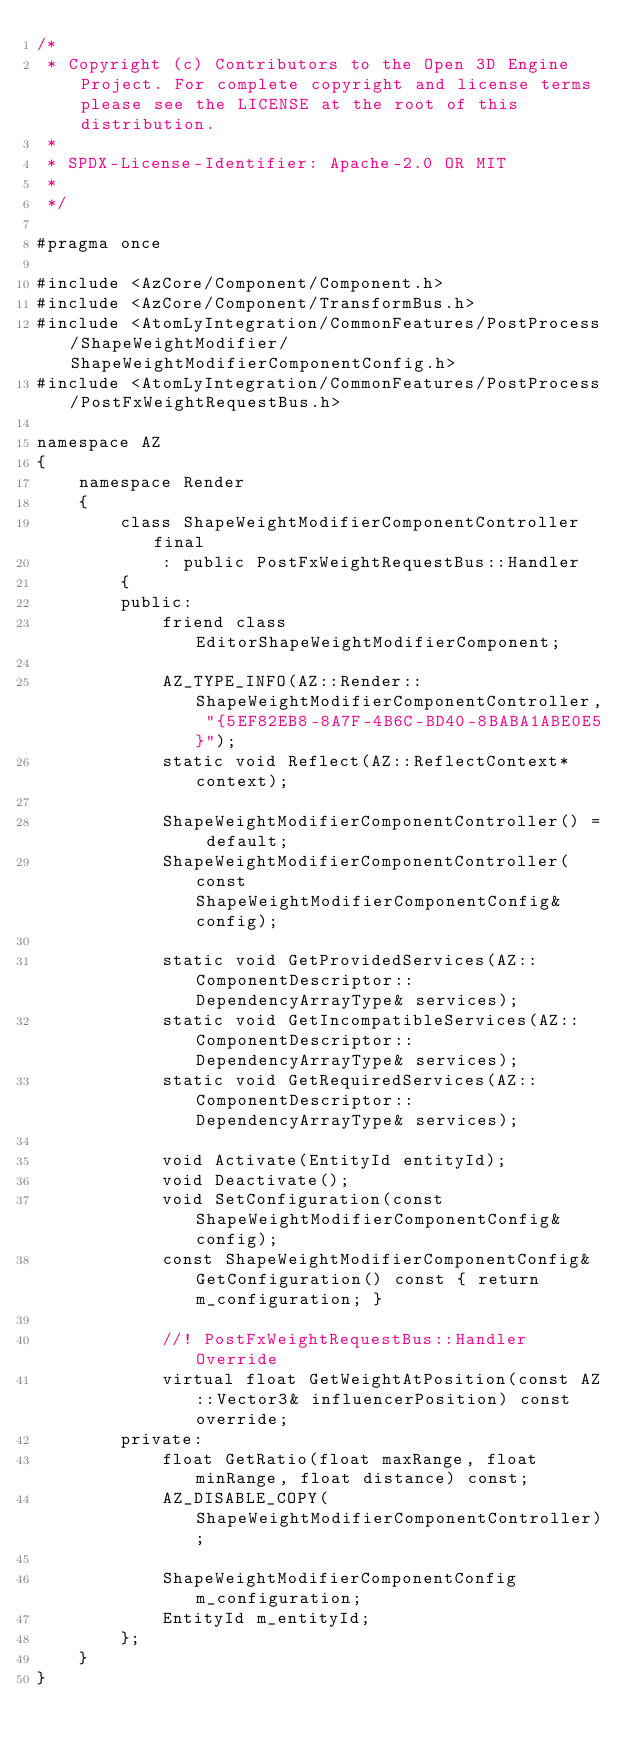Convert code to text. <code><loc_0><loc_0><loc_500><loc_500><_C_>/*
 * Copyright (c) Contributors to the Open 3D Engine Project. For complete copyright and license terms please see the LICENSE at the root of this distribution.
 * 
 * SPDX-License-Identifier: Apache-2.0 OR MIT
 *
 */

#pragma once

#include <AzCore/Component/Component.h>
#include <AzCore/Component/TransformBus.h>
#include <AtomLyIntegration/CommonFeatures/PostProcess/ShapeWeightModifier/ShapeWeightModifierComponentConfig.h>
#include <AtomLyIntegration/CommonFeatures/PostProcess/PostFxWeightRequestBus.h>

namespace AZ
{
    namespace Render
    {
        class ShapeWeightModifierComponentController final
            : public PostFxWeightRequestBus::Handler
        {
        public:
            friend class EditorShapeWeightModifierComponent;

            AZ_TYPE_INFO(AZ::Render::ShapeWeightModifierComponentController, "{5EF82EB8-8A7F-4B6C-BD40-8BABA1ABE0E5}");
            static void Reflect(AZ::ReflectContext* context);

            ShapeWeightModifierComponentController() = default;
            ShapeWeightModifierComponentController(const ShapeWeightModifierComponentConfig& config);

            static void GetProvidedServices(AZ::ComponentDescriptor::DependencyArrayType& services);
            static void GetIncompatibleServices(AZ::ComponentDescriptor::DependencyArrayType& services);
            static void GetRequiredServices(AZ::ComponentDescriptor::DependencyArrayType& services);

            void Activate(EntityId entityId);
            void Deactivate();
            void SetConfiguration(const ShapeWeightModifierComponentConfig& config);
            const ShapeWeightModifierComponentConfig& GetConfiguration() const { return m_configuration; }

            //! PostFxWeightRequestBus::Handler Override
            virtual float GetWeightAtPosition(const AZ::Vector3& influencerPosition) const override;
        private:
            float GetRatio(float maxRange, float minRange, float distance) const;
            AZ_DISABLE_COPY(ShapeWeightModifierComponentController);

            ShapeWeightModifierComponentConfig m_configuration;
            EntityId m_entityId;
        };
    }
}
</code> 